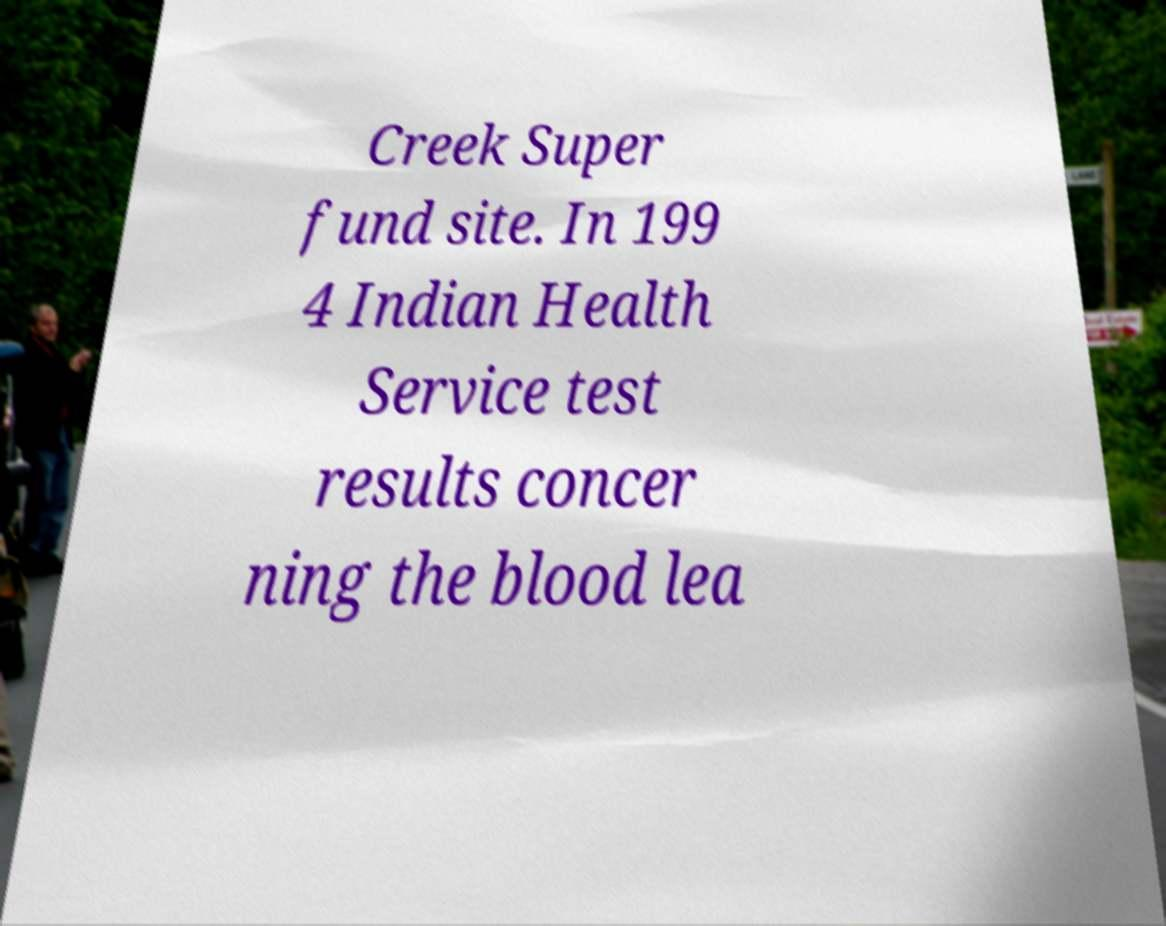I need the written content from this picture converted into text. Can you do that? Creek Super fund site. In 199 4 Indian Health Service test results concer ning the blood lea 